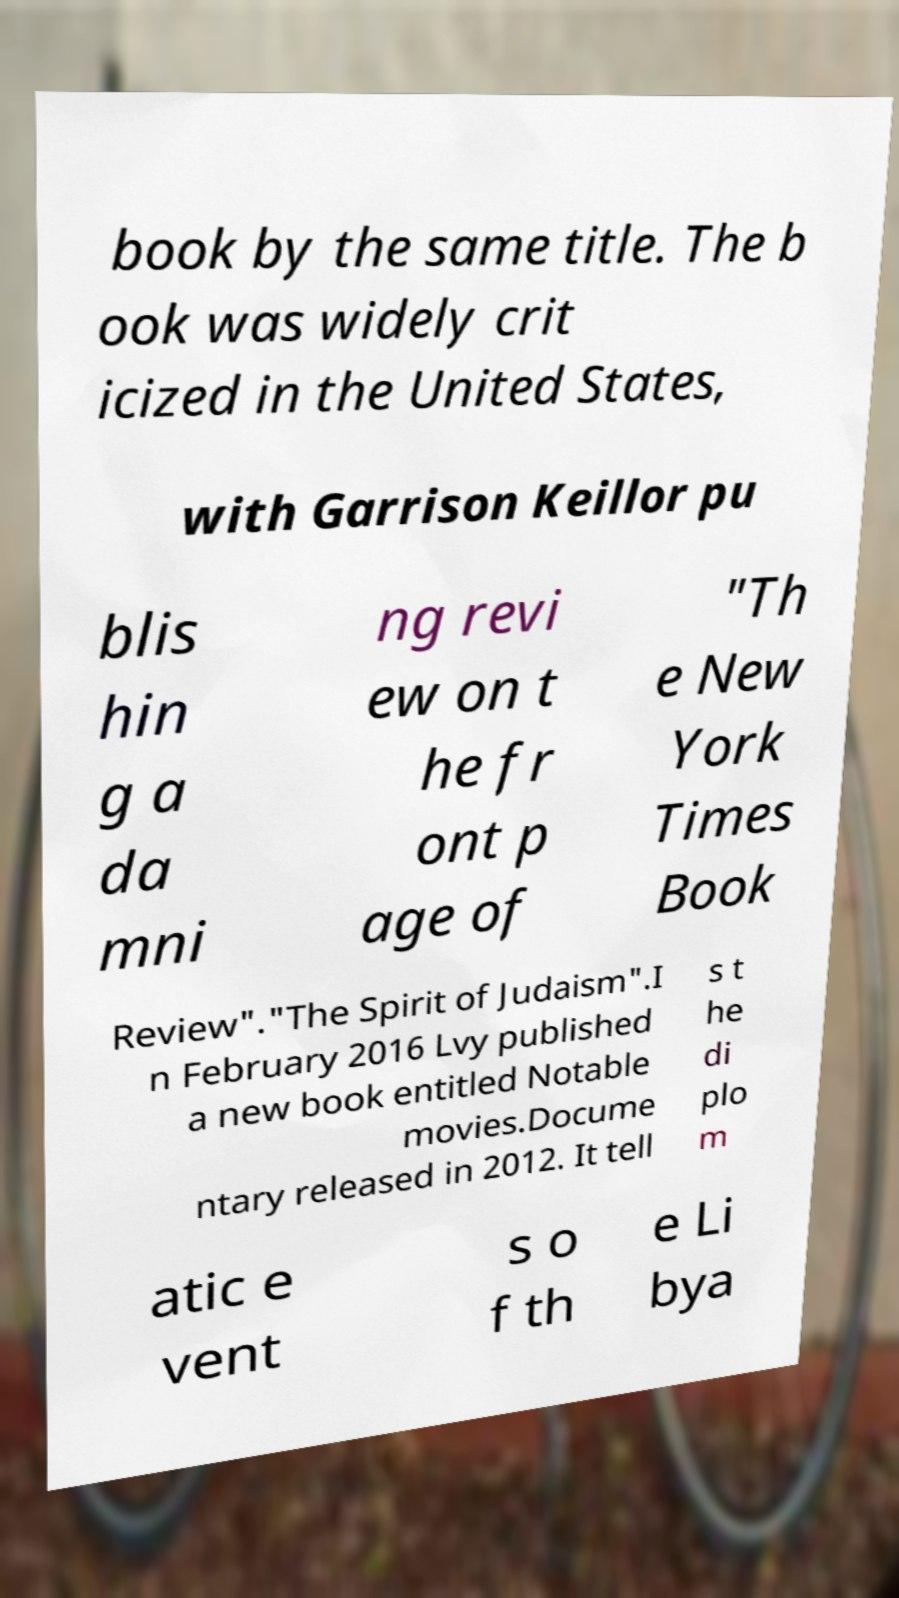Please identify and transcribe the text found in this image. book by the same title. The b ook was widely crit icized in the United States, with Garrison Keillor pu blis hin g a da mni ng revi ew on t he fr ont p age of "Th e New York Times Book Review"."The Spirit of Judaism".I n February 2016 Lvy published a new book entitled Notable movies.Docume ntary released in 2012. It tell s t he di plo m atic e vent s o f th e Li bya 